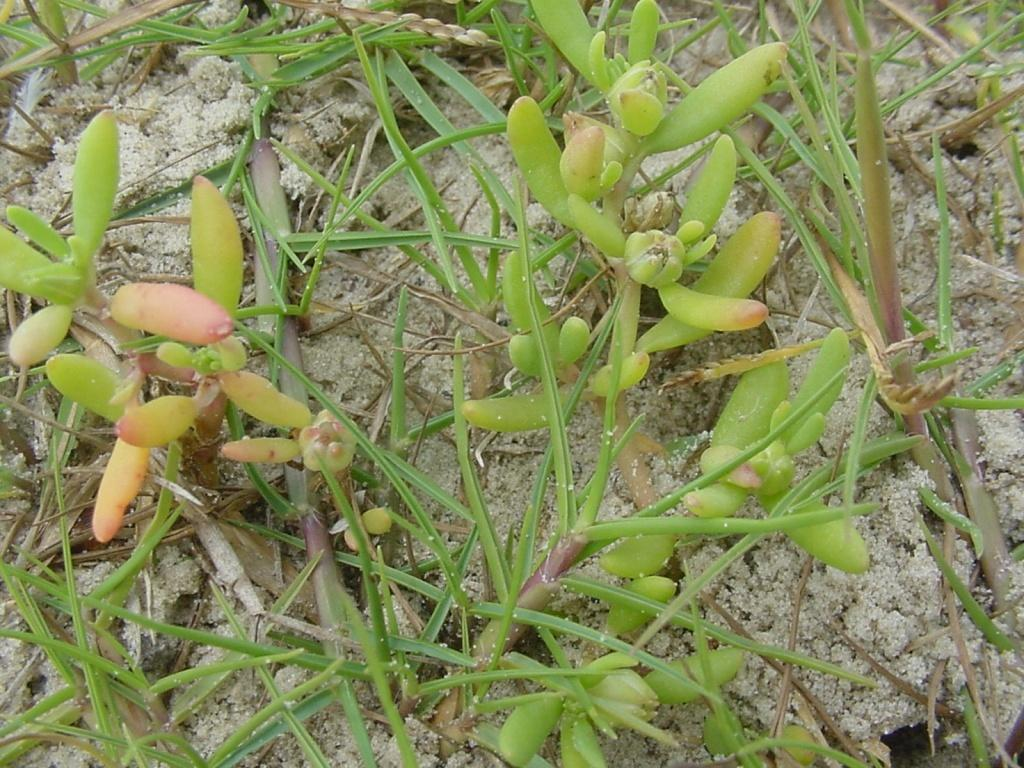What type of living organisms can be seen in the image? Plants can be seen in the image. What stage of growth are some of the plants in? There are buds in the image, which indicates that some plants are in the early stages of growth. What type of terrain is visible in the image? Sand is visible in the image. What type of harmony can be heard in the image? There is no audible element in the image, so it is not possible to determine if any harmony can be heard. 